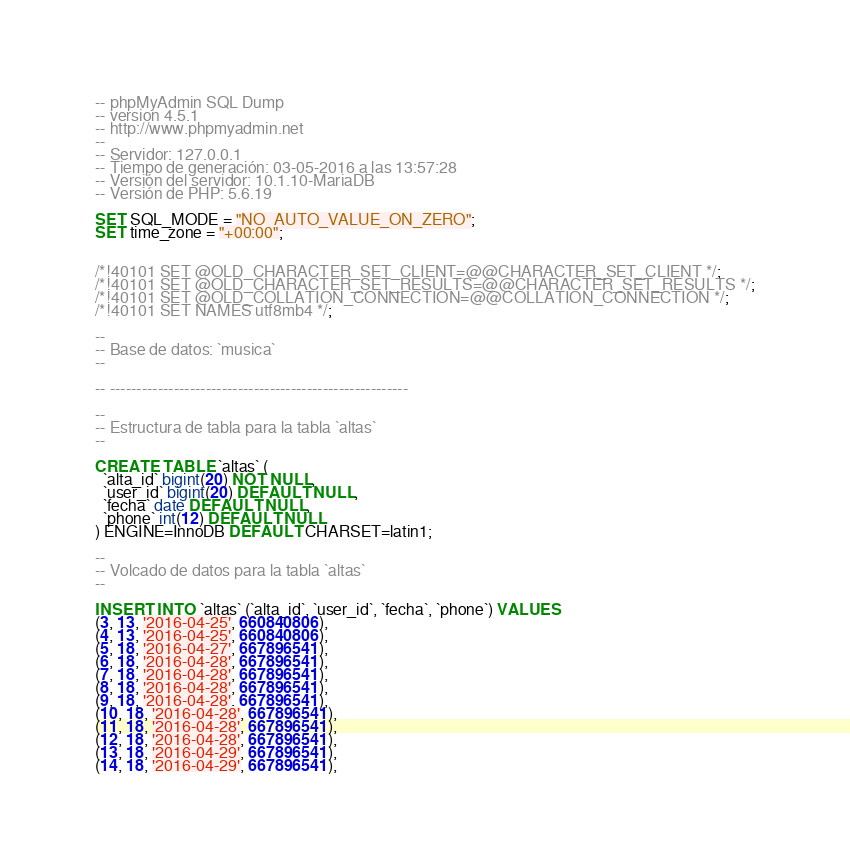Convert code to text. <code><loc_0><loc_0><loc_500><loc_500><_SQL_>-- phpMyAdmin SQL Dump
-- version 4.5.1
-- http://www.phpmyadmin.net
--
-- Servidor: 127.0.0.1
-- Tiempo de generación: 03-05-2016 a las 13:57:28
-- Versión del servidor: 10.1.10-MariaDB
-- Versión de PHP: 5.6.19

SET SQL_MODE = "NO_AUTO_VALUE_ON_ZERO";
SET time_zone = "+00:00";


/*!40101 SET @OLD_CHARACTER_SET_CLIENT=@@CHARACTER_SET_CLIENT */;
/*!40101 SET @OLD_CHARACTER_SET_RESULTS=@@CHARACTER_SET_RESULTS */;
/*!40101 SET @OLD_COLLATION_CONNECTION=@@COLLATION_CONNECTION */;
/*!40101 SET NAMES utf8mb4 */;

--
-- Base de datos: `musica`
--

-- --------------------------------------------------------

--
-- Estructura de tabla para la tabla `altas`
--

CREATE TABLE `altas` (
  `alta_id` bigint(20) NOT NULL,
  `user_id` bigint(20) DEFAULT NULL,
  `fecha` date DEFAULT NULL,
  `phone` int(12) DEFAULT NULL
) ENGINE=InnoDB DEFAULT CHARSET=latin1;

--
-- Volcado de datos para la tabla `altas`
--

INSERT INTO `altas` (`alta_id`, `user_id`, `fecha`, `phone`) VALUES
(3, 13, '2016-04-25', 660840806),
(4, 13, '2016-04-25', 660840806),
(5, 18, '2016-04-27', 667896541),
(6, 18, '2016-04-28', 667896541),
(7, 18, '2016-04-28', 667896541),
(8, 18, '2016-04-28', 667896541),
(9, 18, '2016-04-28', 667896541),
(10, 18, '2016-04-28', 667896541),
(11, 18, '2016-04-28', 667896541),
(12, 18, '2016-04-28', 667896541),
(13, 18, '2016-04-29', 667896541),
(14, 18, '2016-04-29', 667896541),</code> 